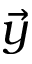<formula> <loc_0><loc_0><loc_500><loc_500>\vec { y }</formula> 